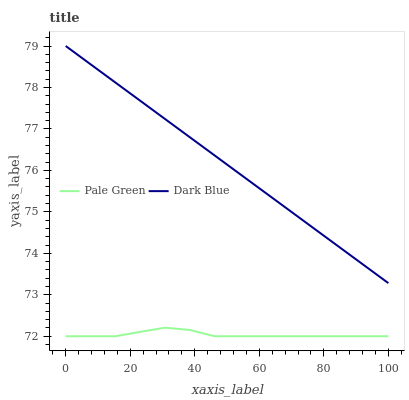Does Pale Green have the minimum area under the curve?
Answer yes or no. Yes. Does Dark Blue have the maximum area under the curve?
Answer yes or no. Yes. Does Pale Green have the maximum area under the curve?
Answer yes or no. No. Is Dark Blue the smoothest?
Answer yes or no. Yes. Is Pale Green the roughest?
Answer yes or no. Yes. Is Pale Green the smoothest?
Answer yes or no. No. Does Pale Green have the lowest value?
Answer yes or no. Yes. Does Dark Blue have the highest value?
Answer yes or no. Yes. Does Pale Green have the highest value?
Answer yes or no. No. Is Pale Green less than Dark Blue?
Answer yes or no. Yes. Is Dark Blue greater than Pale Green?
Answer yes or no. Yes. Does Pale Green intersect Dark Blue?
Answer yes or no. No. 